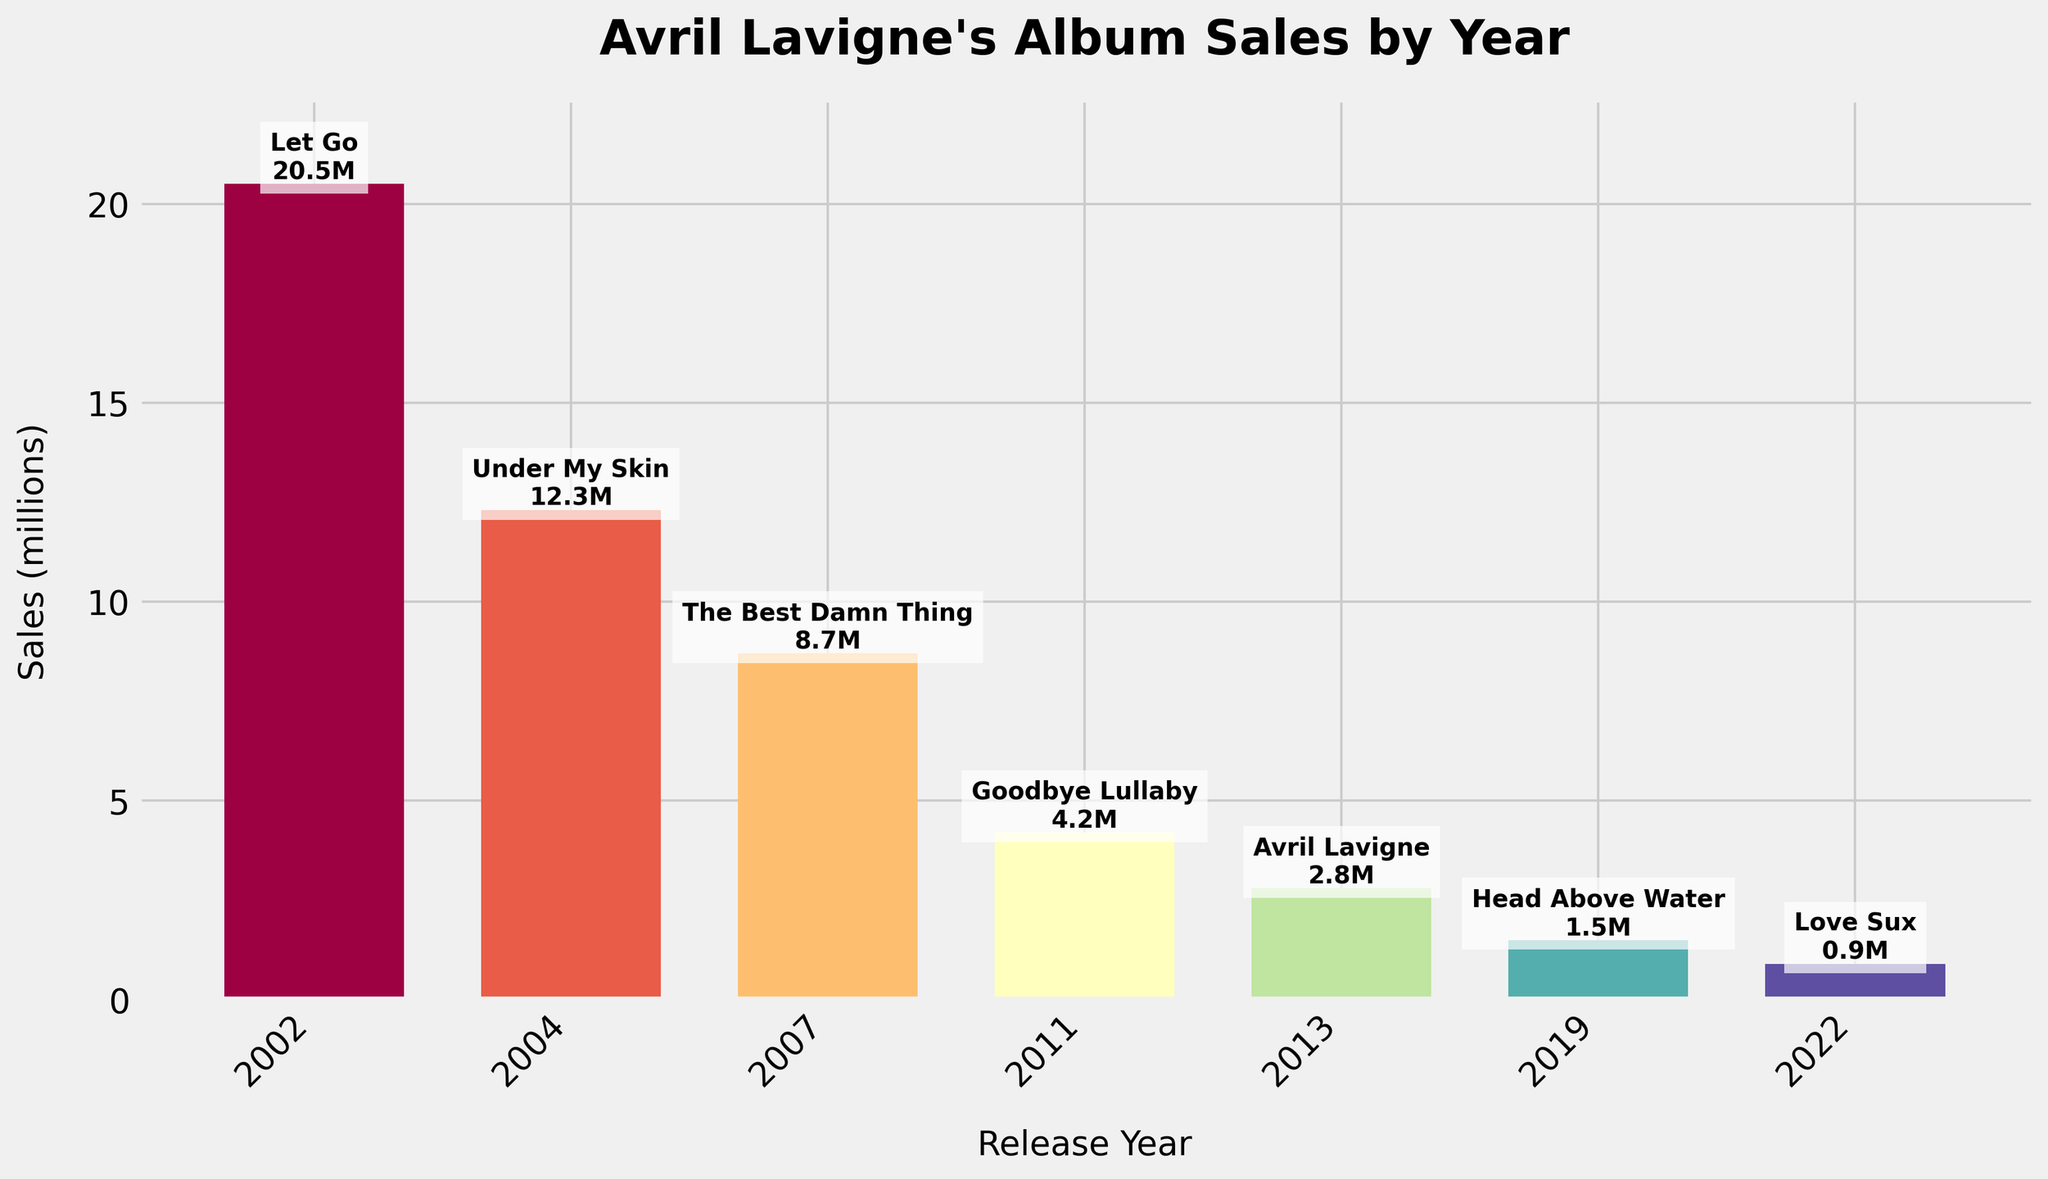What's the best-selling album by Avril Lavigne according to the chart? To determine this, look for the highest bar on the chart and identify the corresponding album. The tallest bar is for the album "Let Go," with sales of 20.5 million.
Answer: Let Go Which album has the lowest sales figure? To find the album with the lowest sales, check the shortest bar on the chart and identify the corresponding album. The shortest bar represents the album "Love Sux," with sales of 0.9 million.
Answer: Love Sux How do the sales of "Under My Skin" (2004) compare to "Avril Lavigne" (2013)? Compare the heights of the bars representing the albums released in 2004 and 2013. "Under My Skin" has higher sales (12.3 million) compared to "Avril Lavigne" (2.8 million).
Answer: Under My Skin has higher sales What's the difference in sales between "Goodbye Lullaby" and "Head Above Water"? Identify the sales figures of both albums (4.2 million for "Goodbye Lullaby" and 1.5 million for "Head Above Water") and subtract the smaller from the larger: 4.2 - 1.5 = 2.7 million.
Answer: 2.7 million What are the average sales of Avril Lavigne’s albums released in the 2010s (2011, 2013, and 2019)? Add the sales figures from 2011, 2013, and 2019 (4.2 + 2.8 + 1.5 = 8.5 million) and divide by the number of albums (3): 8.5 / 3 ≈ 2.83 million.
Answer: 2.83 million How many albums had sales figures above 5 million? Identify the bars with heights above 5 million. The albums "Let Go," "Under My Skin," and "The Best Damn Thing" meet this criterion. There are 3 such albums.
Answer: 3 Which album had the higher sales when comparing "Love Sux" and "Head Above Water"? Compare the heights of the bars for the albums released in 2019 ("Head Above Water") and 2022 ("Love Sux"). "Head Above Water" (1.5 million) has higher sales than "Love Sux" (0.9 million).
Answer: Head Above Water What is the total sales of albums released before 2010? Sum the sales figures of the albums released in 2002, 2004, and 2007: 20.5 + 12.3 + 8.7 = 41.5 million.
Answer: 41.5 million How much more did "The Best Damn Thing" sell compared to "Goodbye Lullaby"? Identify the sales figures for both albums (8.7 million for "The Best Damn Thing" and 4.2 million for "Goodbye Lullaby") and find the difference: 8.7 - 4.2 = 4.5 million.
Answer: 4.5 million 